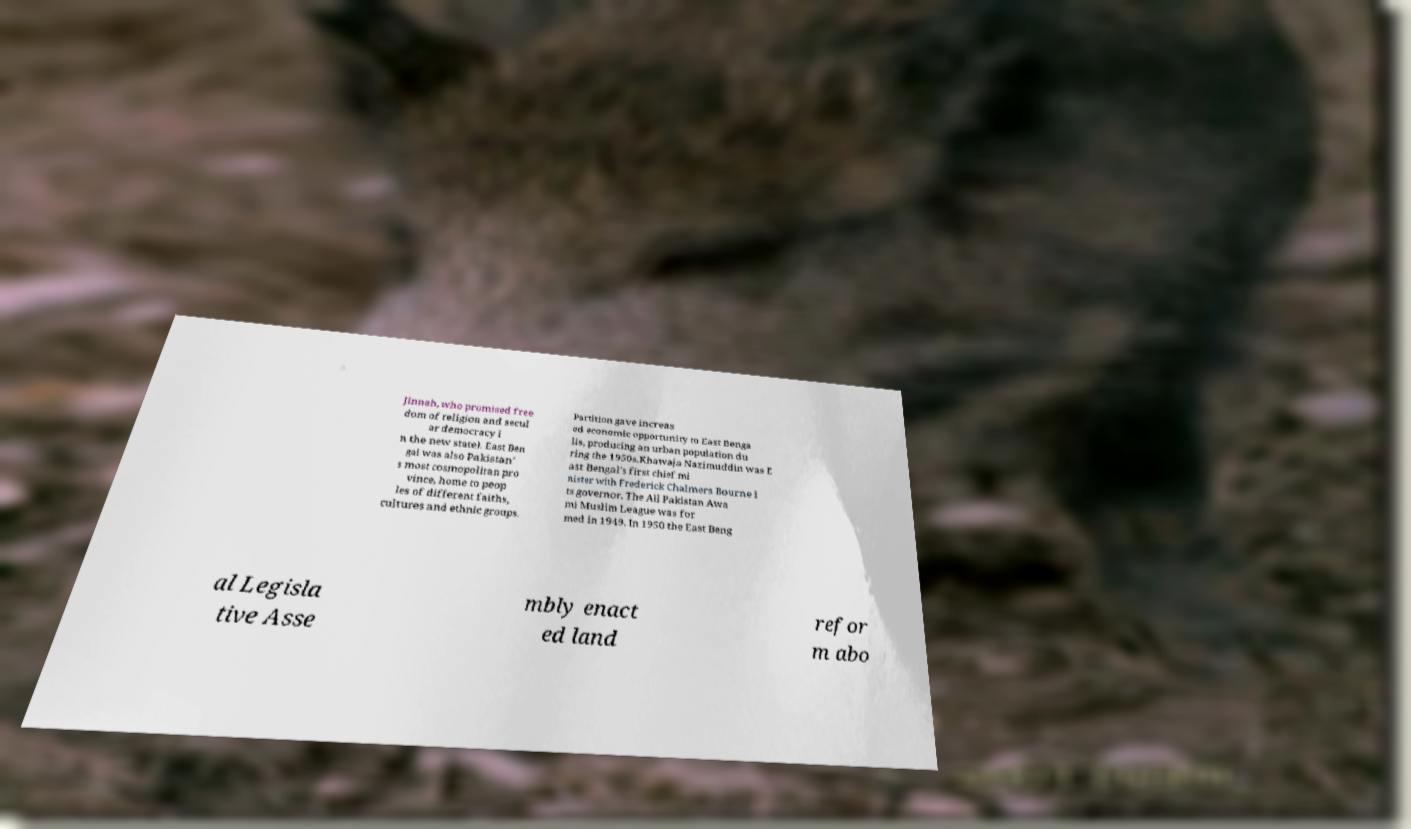Could you extract and type out the text from this image? Jinnah, who promised free dom of religion and secul ar democracy i n the new state). East Ben gal was also Pakistan' s most cosmopolitan pro vince, home to peop les of different faiths, cultures and ethnic groups. Partition gave increas ed economic opportunity to East Benga lis, producing an urban population du ring the 1950s.Khawaja Nazimuddin was E ast Bengal's first chief mi nister with Frederick Chalmers Bourne i ts governor. The All Pakistan Awa mi Muslim League was for med in 1949. In 1950 the East Beng al Legisla tive Asse mbly enact ed land refor m abo 